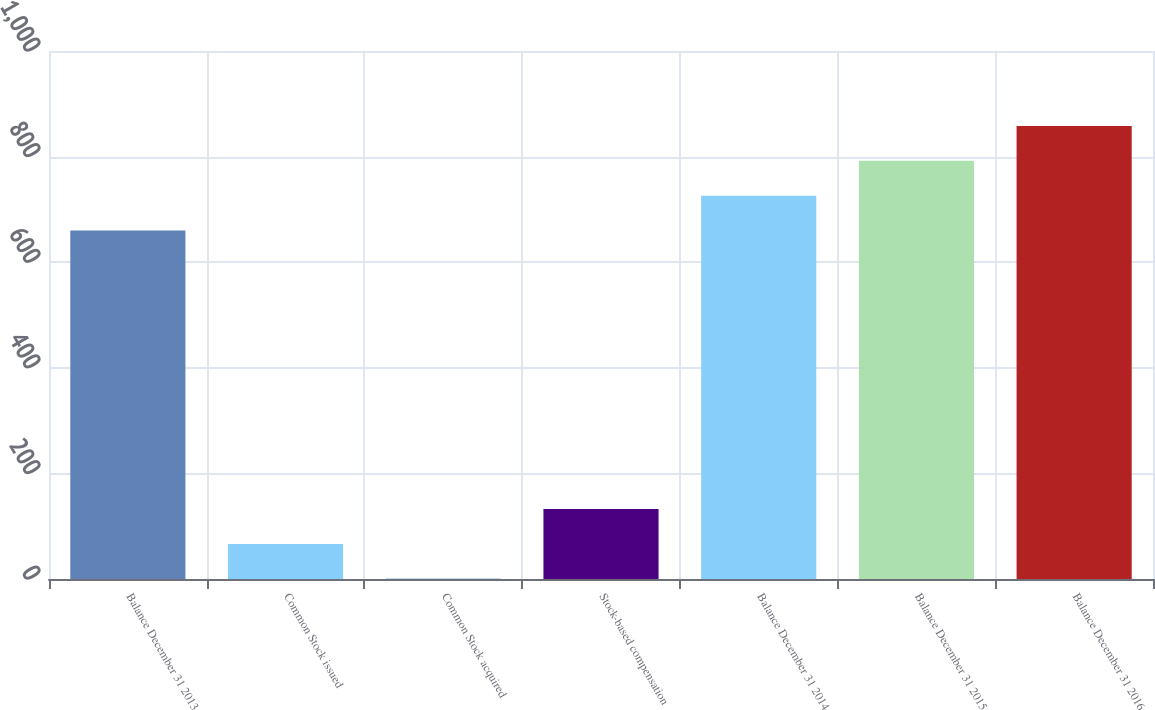Convert chart to OTSL. <chart><loc_0><loc_0><loc_500><loc_500><bar_chart><fcel>Balance December 31 2013<fcel>Common Stock issued<fcel>Common Stock acquired<fcel>Stock-based compensation<fcel>Balance December 31 2014<fcel>Balance December 31 2015<fcel>Balance December 31 2016<nl><fcel>660.1<fcel>66.43<fcel>0.47<fcel>132.39<fcel>726.06<fcel>792.02<fcel>857.98<nl></chart> 